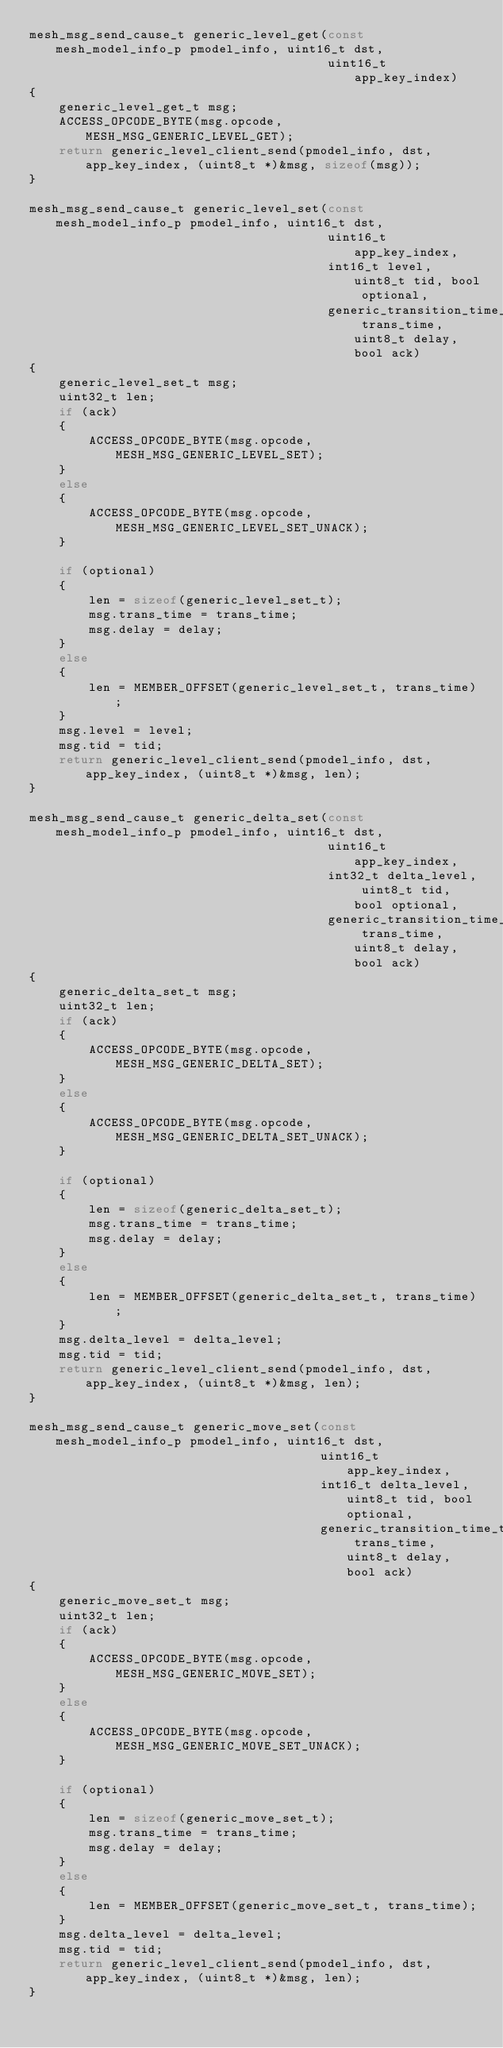<code> <loc_0><loc_0><loc_500><loc_500><_C_>mesh_msg_send_cause_t generic_level_get(const mesh_model_info_p pmodel_info, uint16_t dst,
                                        uint16_t app_key_index)
{
    generic_level_get_t msg;
    ACCESS_OPCODE_BYTE(msg.opcode, MESH_MSG_GENERIC_LEVEL_GET);
    return generic_level_client_send(pmodel_info, dst, app_key_index, (uint8_t *)&msg, sizeof(msg));
}

mesh_msg_send_cause_t generic_level_set(const mesh_model_info_p pmodel_info, uint16_t dst,
                                        uint16_t app_key_index,
                                        int16_t level, uint8_t tid, bool optional,
                                        generic_transition_time_t trans_time, uint8_t delay, bool ack)
{
    generic_level_set_t msg;
    uint32_t len;
    if (ack)
    {
        ACCESS_OPCODE_BYTE(msg.opcode, MESH_MSG_GENERIC_LEVEL_SET);
    }
    else
    {
        ACCESS_OPCODE_BYTE(msg.opcode, MESH_MSG_GENERIC_LEVEL_SET_UNACK);
    }

    if (optional)
    {
        len = sizeof(generic_level_set_t);
        msg.trans_time = trans_time;
        msg.delay = delay;
    }
    else
    {
        len = MEMBER_OFFSET(generic_level_set_t, trans_time);
    }
    msg.level = level;
    msg.tid = tid;
    return generic_level_client_send(pmodel_info, dst, app_key_index, (uint8_t *)&msg, len);
}

mesh_msg_send_cause_t generic_delta_set(const mesh_model_info_p pmodel_info, uint16_t dst,
                                        uint16_t app_key_index,
                                        int32_t delta_level, uint8_t tid, bool optional,
                                        generic_transition_time_t trans_time, uint8_t delay, bool ack)
{
    generic_delta_set_t msg;
    uint32_t len;
    if (ack)
    {
        ACCESS_OPCODE_BYTE(msg.opcode, MESH_MSG_GENERIC_DELTA_SET);
    }
    else
    {
        ACCESS_OPCODE_BYTE(msg.opcode, MESH_MSG_GENERIC_DELTA_SET_UNACK);
    }

    if (optional)
    {
        len = sizeof(generic_delta_set_t);
        msg.trans_time = trans_time;
        msg.delay = delay;
    }
    else
    {
        len = MEMBER_OFFSET(generic_delta_set_t, trans_time);
    }
    msg.delta_level = delta_level;
    msg.tid = tid;
    return generic_level_client_send(pmodel_info, dst, app_key_index, (uint8_t *)&msg, len);
}

mesh_msg_send_cause_t generic_move_set(const mesh_model_info_p pmodel_info, uint16_t dst,
                                       uint16_t app_key_index,
                                       int16_t delta_level, uint8_t tid, bool optional,
                                       generic_transition_time_t trans_time, uint8_t delay, bool ack)
{
    generic_move_set_t msg;
    uint32_t len;
    if (ack)
    {
        ACCESS_OPCODE_BYTE(msg.opcode, MESH_MSG_GENERIC_MOVE_SET);
    }
    else
    {
        ACCESS_OPCODE_BYTE(msg.opcode, MESH_MSG_GENERIC_MOVE_SET_UNACK);
    }

    if (optional)
    {
        len = sizeof(generic_move_set_t);
        msg.trans_time = trans_time;
        msg.delay = delay;
    }
    else
    {
        len = MEMBER_OFFSET(generic_move_set_t, trans_time);
    }
    msg.delta_level = delta_level;
    msg.tid = tid;
    return generic_level_client_send(pmodel_info, dst, app_key_index, (uint8_t *)&msg, len);
}</code> 